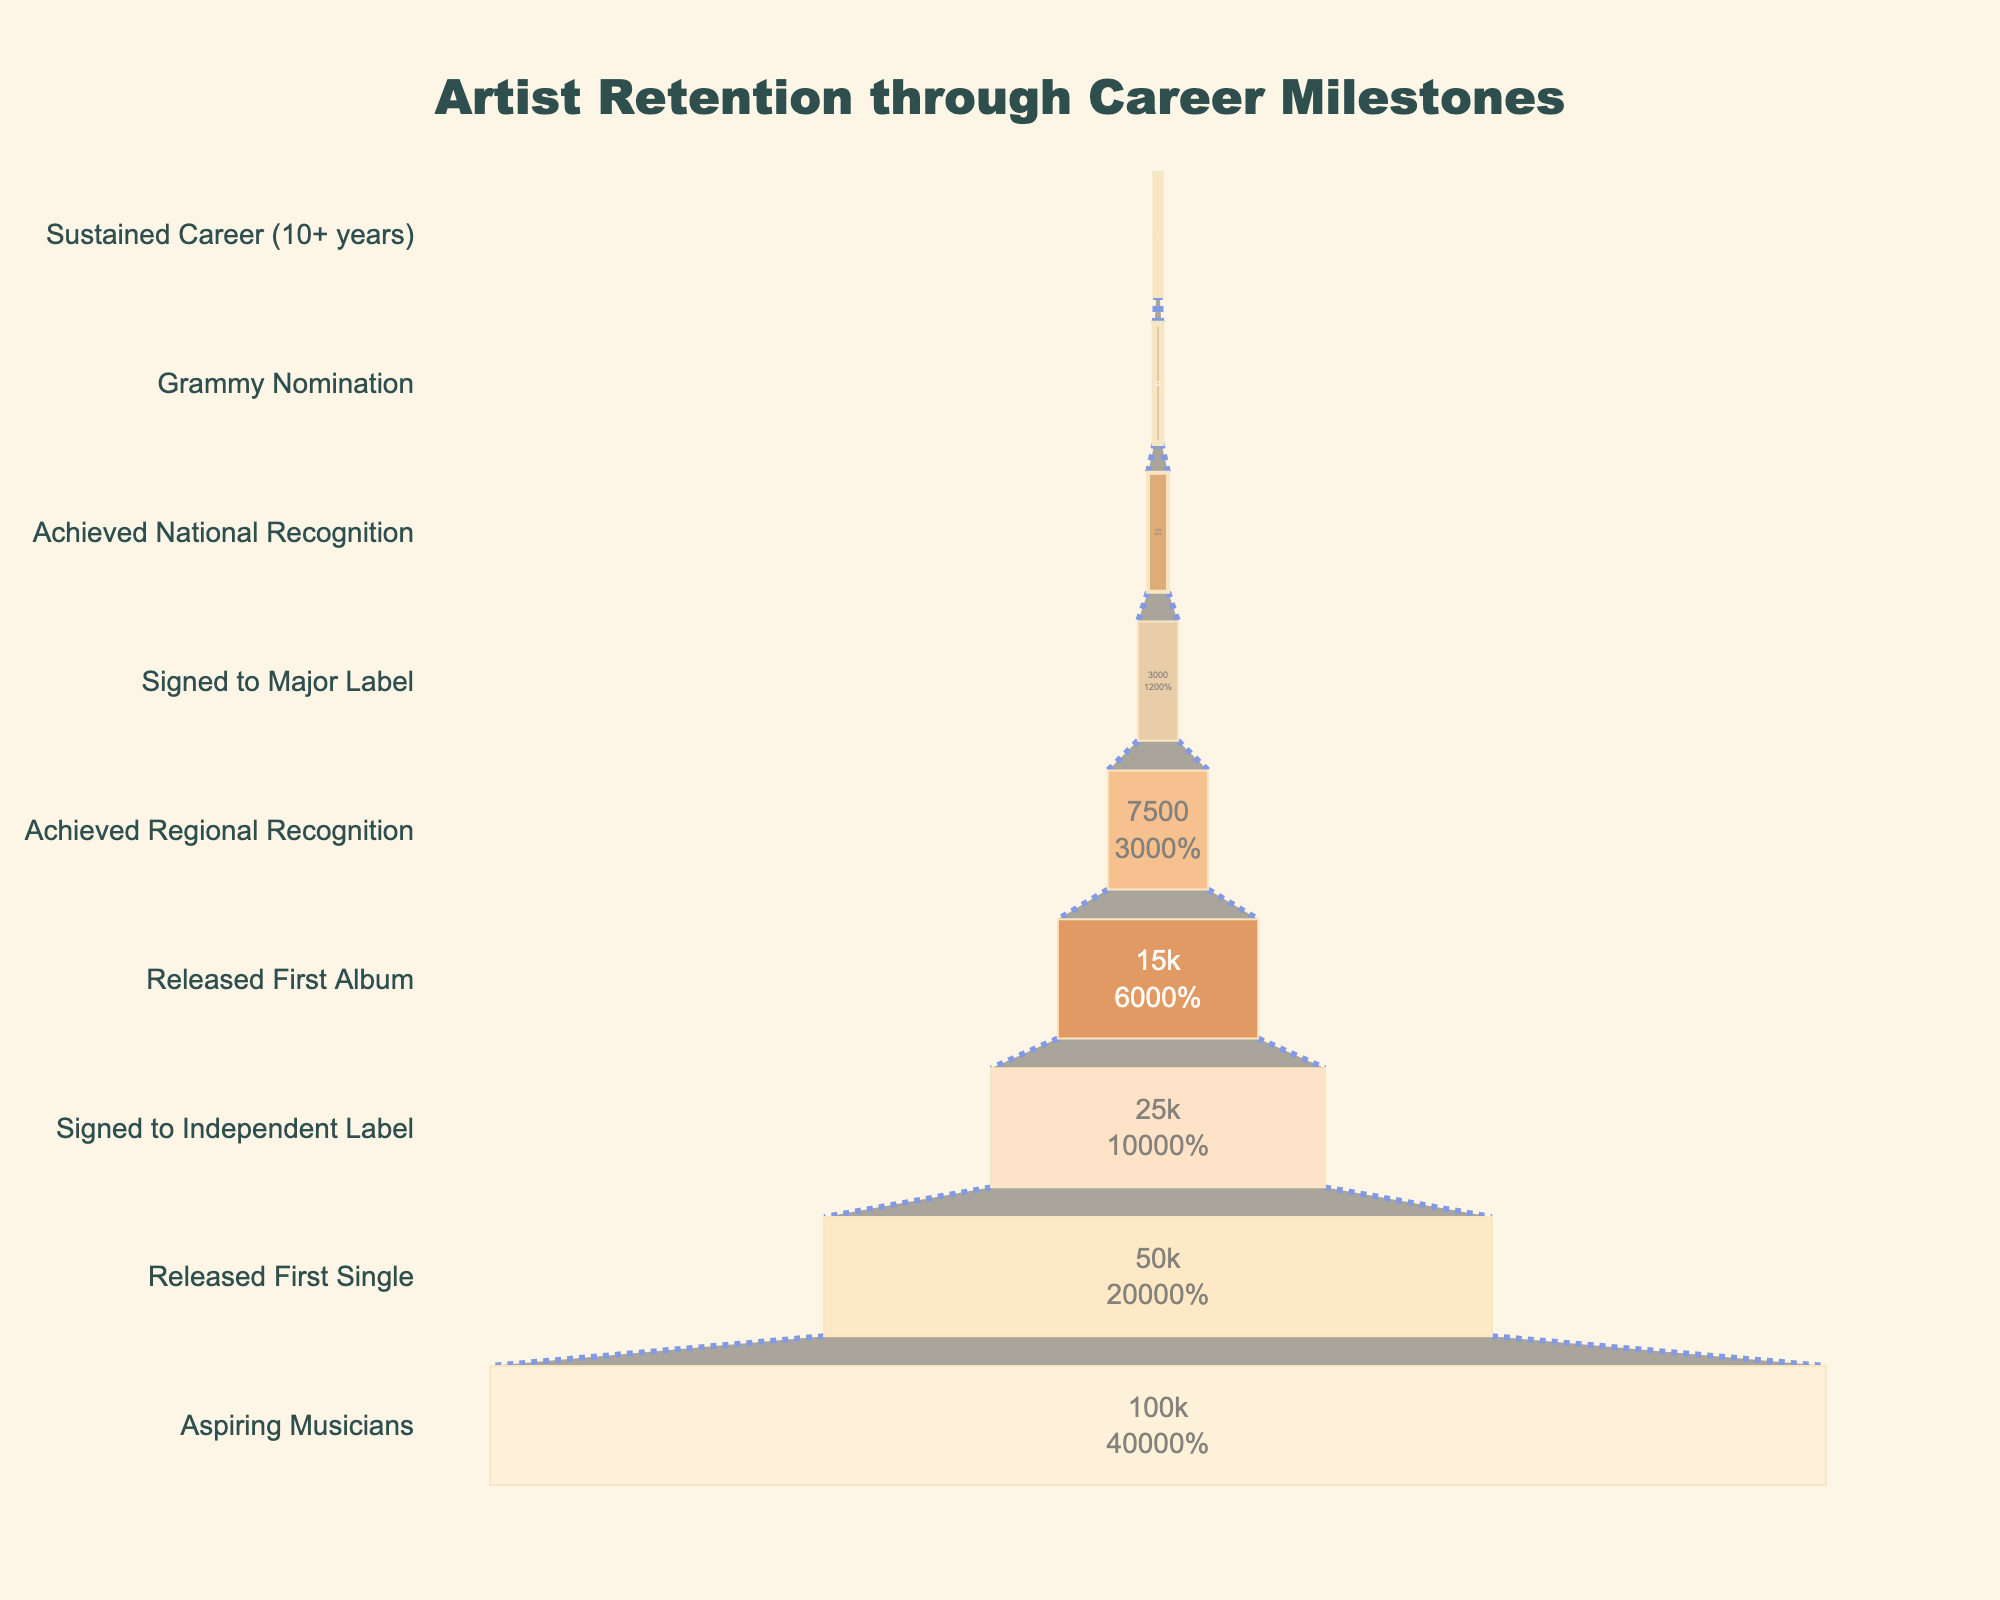How many stages are there for artist retention in the funnel chart? First identify all the stages listed on the y-axis of the funnel chart. Count the stages from "Aspiring Musicians" at the bottom to "Sustained Career (10+ years)" at the top.
Answer: 9 What is the percentage of artists that released their first single out of those aspiring to be musicians? Look at the number of artists in "Aspiring Musicians" (100,000) and those in "Released First Single" (50,000). Calculate the percentage using (50,000 / 100,000) * 100%.
Answer: 50% How does the number of artists who signed to a major label compare to those who achieved national recognition? Check the values for "Signed to Major Label" (3,000) and "Achieved National Recognition" (1,500). Compare the two numbers by noting that 3,000 is greater than 1,500.
Answer: 3,000 is greater What is the drop rate of artists between releasing their first album and achieving regional recognition? Look at the number of artists in "Released First Album" (15,000) and "Achieved Regional Recognition" (7,500). Calculate the drop rate using (15,000 - 7,500) / 15,000 * 100%.
Answer: 50% Which stage has the smallest number of artists remaining? Identify the stage with the lowest value on the x-axis by scanning from top to bottom. "Sustained Career (10+ years)" has the smallest number, which is 250.
Answer: Sustained Career (10+ years) What fraction of artists who achieved regional recognition go on to get signed to a major label? Look at the number of artists in "Achieved Regional Recognition" (7,500) and "Signed to Major Label" (3,000). Calculate the fraction using 3,000 / 7,500.
Answer: 0.4 How many artists have a sustained career of more than ten years? Directly refer to the number of artists in the stage "Sustained Career (10+ years)", which is 250.
Answer: 250 What milestone marks a transition from a regional to a more national level of recognition? Find stages related to recognition levels. "Achieved Regional Recognition" transitions to "Signed to Major Label" followed by "Achieved National Recognition".
Answer: Signed to Major Label How many artists transition from being signed to an independent label to releasing their first album? Check the numbers for "Signed to Independent Label" (25,000) and "Released First Album" (15,000). The number of transitioning artists is 25,000 - 15,000 = 10,000.
Answer: 10,000 